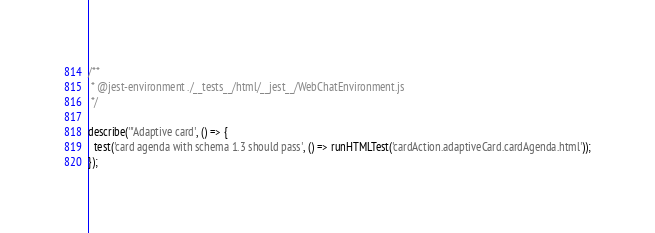<code> <loc_0><loc_0><loc_500><loc_500><_JavaScript_>/**
 * @jest-environment ./__tests__/html/__jest__/WebChatEnvironment.js
 */

describe('"Adaptive card', () => {
  test('card agenda with schema 1.3 should pass', () => runHTMLTest('cardAction.adaptiveCard.cardAgenda.html'));
});
</code> 